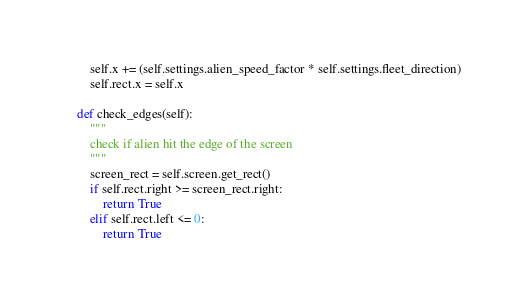Convert code to text. <code><loc_0><loc_0><loc_500><loc_500><_Python_>        self.x += (self.settings.alien_speed_factor * self.settings.fleet_direction)
        self.rect.x = self.x

    def check_edges(self):
        """
        check if alien hit the edge of the screen
        """
        screen_rect = self.screen.get_rect()
        if self.rect.right >= screen_rect.right:
            return True
        elif self.rect.left <= 0:
            return True

</code> 